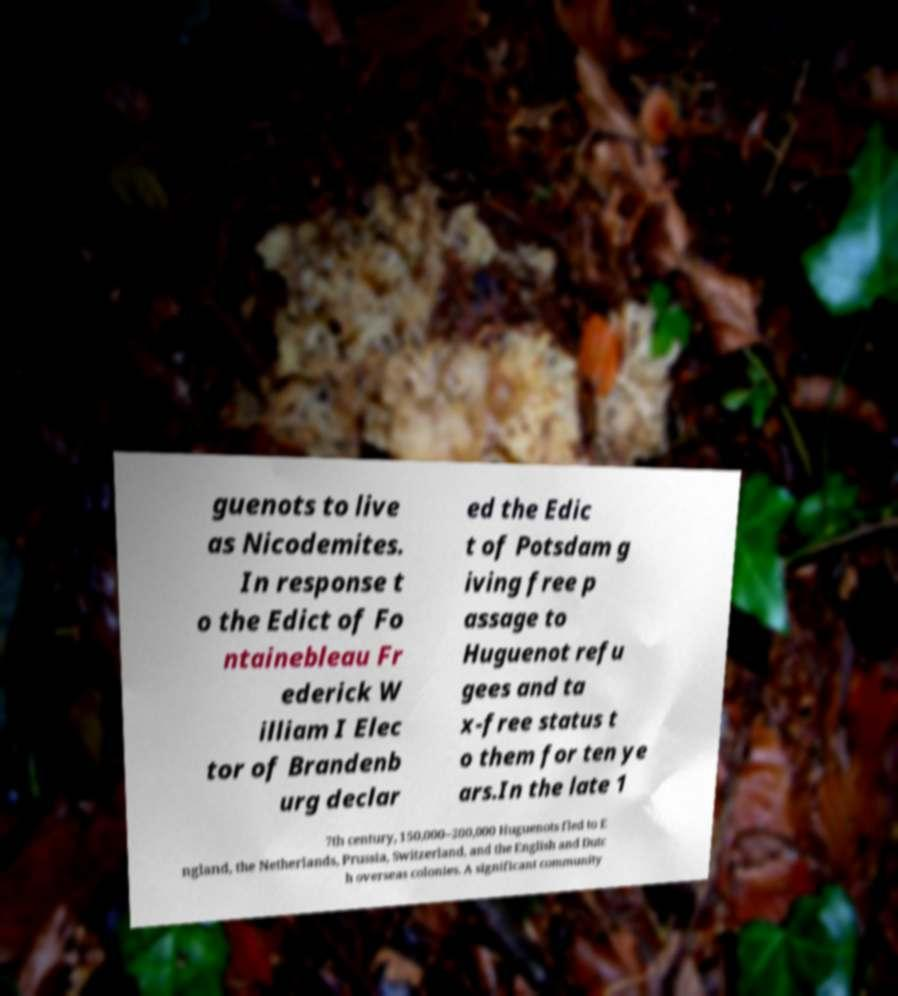Please read and relay the text visible in this image. What does it say? guenots to live as Nicodemites. In response t o the Edict of Fo ntainebleau Fr ederick W illiam I Elec tor of Brandenb urg declar ed the Edic t of Potsdam g iving free p assage to Huguenot refu gees and ta x-free status t o them for ten ye ars.In the late 1 7th century, 150,000–200,000 Huguenots fled to E ngland, the Netherlands, Prussia, Switzerland, and the English and Dutc h overseas colonies. A significant community 